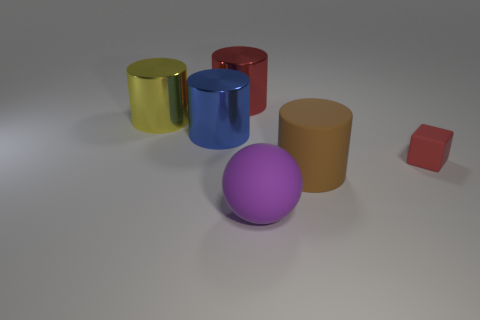Subtract all large brown cylinders. How many cylinders are left? 3 Add 1 small shiny objects. How many objects exist? 7 Subtract all blue cylinders. How many cylinders are left? 3 Subtract 1 cubes. How many cubes are left? 0 Subtract all spheres. How many objects are left? 5 Add 3 big yellow cylinders. How many big yellow cylinders are left? 4 Add 2 blue things. How many blue things exist? 3 Subtract 0 green spheres. How many objects are left? 6 Subtract all yellow cylinders. Subtract all cyan spheres. How many cylinders are left? 3 Subtract all small cyan cubes. Subtract all spheres. How many objects are left? 5 